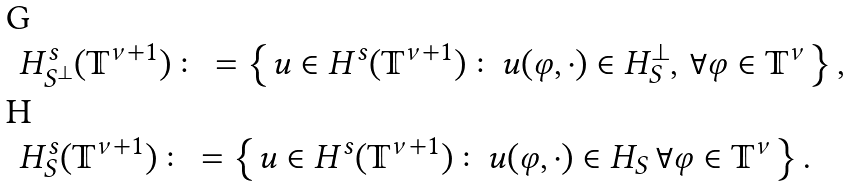Convert formula to latex. <formula><loc_0><loc_0><loc_500><loc_500>& H ^ { s } _ { S ^ { \perp } } ( \mathbb { T } ^ { \nu + 1 } ) \colon = \left \{ u \in H ^ { s } ( \mathbb { T } ^ { \nu + 1 } ) \colon u ( \varphi , \cdot ) \in H _ { S } ^ { \perp } , \, \forall \varphi \in \mathbb { T } ^ { \nu } \right \} , \\ & H ^ { s } _ { S } ( \mathbb { T } ^ { \nu + 1 } ) \colon = \left \{ u \in H ^ { s } ( \mathbb { T } ^ { \nu + 1 } ) \colon u ( \varphi , \cdot ) \in H _ { S } \, \forall \varphi \in \mathbb { T } ^ { \nu } \right \} .</formula> 